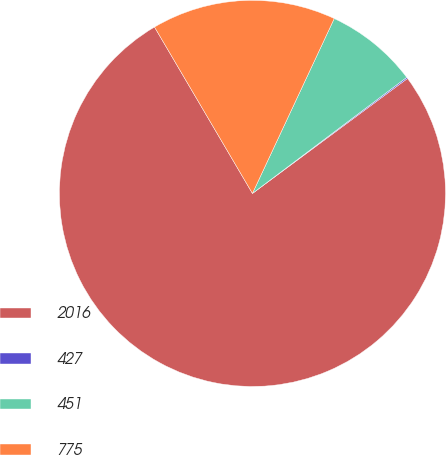<chart> <loc_0><loc_0><loc_500><loc_500><pie_chart><fcel>2016<fcel>427<fcel>451<fcel>775<nl><fcel>76.68%<fcel>0.11%<fcel>7.77%<fcel>15.43%<nl></chart> 